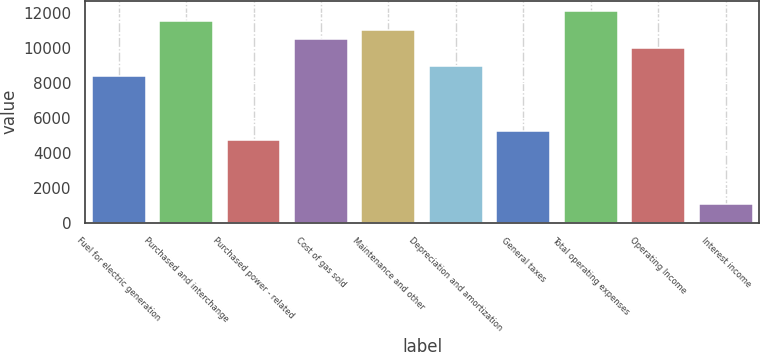Convert chart to OTSL. <chart><loc_0><loc_0><loc_500><loc_500><bar_chart><fcel>Fuel for electric generation<fcel>Purchased and interchange<fcel>Purchased power - related<fcel>Cost of gas sold<fcel>Maintenance and other<fcel>Depreciation and amortization<fcel>General taxes<fcel>Total operating expenses<fcel>Operating Income<fcel>Interest income<nl><fcel>8398.8<fcel>11547.6<fcel>4725.2<fcel>10498<fcel>11022.8<fcel>8923.6<fcel>5250<fcel>12072.4<fcel>9973.2<fcel>1051.6<nl></chart> 